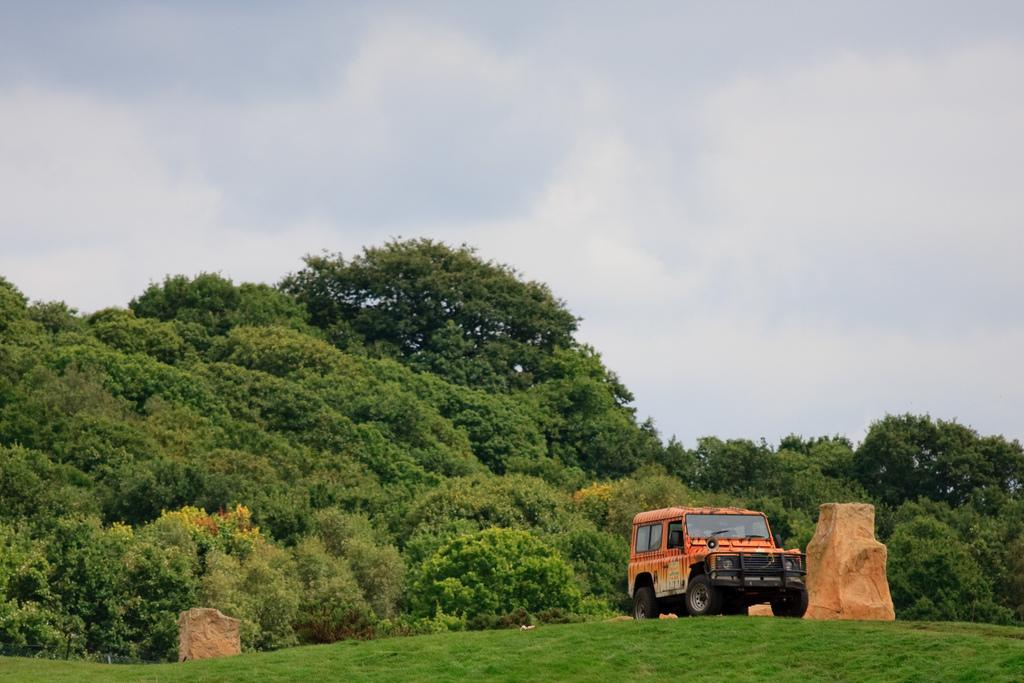What is the condition of the sky in the image? The sky is cloudy in the image. What type of vegetation covers the land in the image? The land is covered with grass in the image. What can be seen in the background of the image? There are trees and a vehicle in the background of the image. How many toes are visible on the vehicle in the image? There are no toes visible in the image, as the image features a vehicle and not a person or animal. 